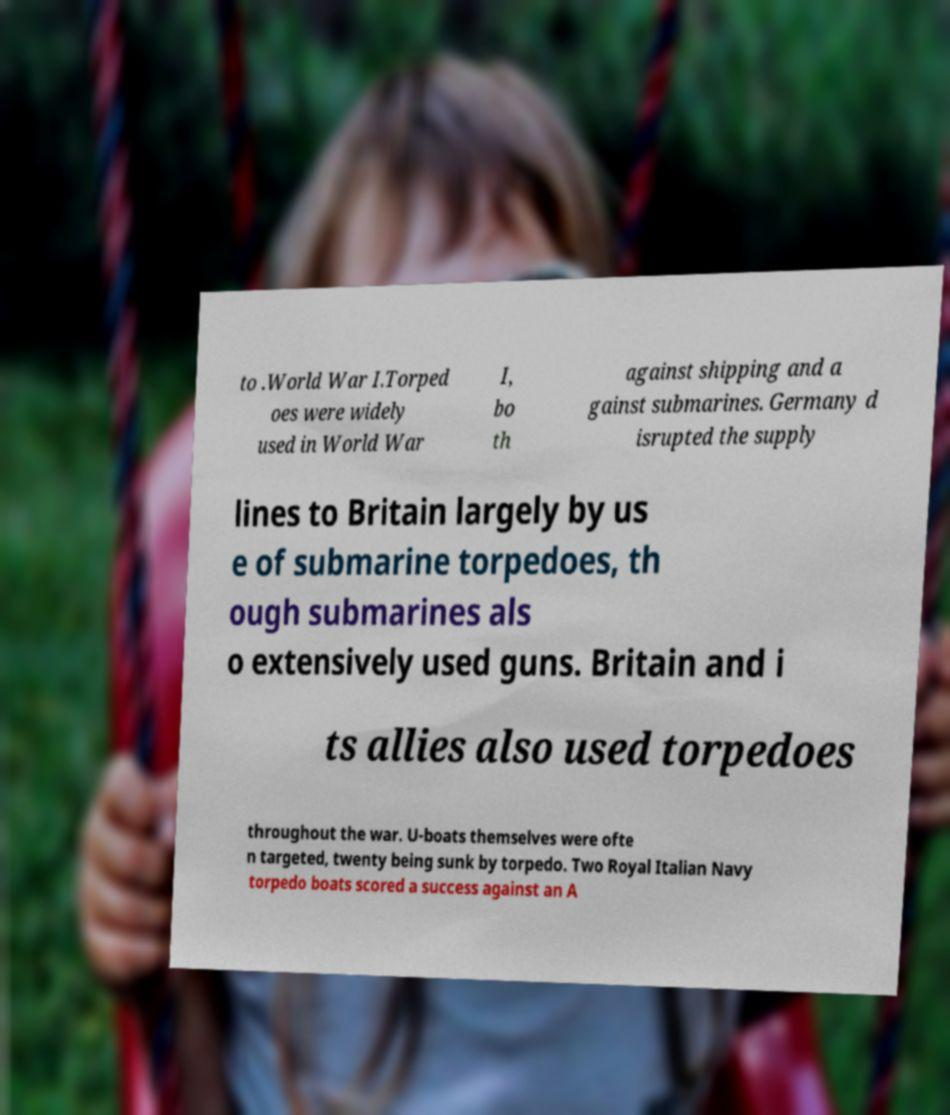Could you extract and type out the text from this image? to .World War I.Torped oes were widely used in World War I, bo th against shipping and a gainst submarines. Germany d isrupted the supply lines to Britain largely by us e of submarine torpedoes, th ough submarines als o extensively used guns. Britain and i ts allies also used torpedoes throughout the war. U-boats themselves were ofte n targeted, twenty being sunk by torpedo. Two Royal Italian Navy torpedo boats scored a success against an A 